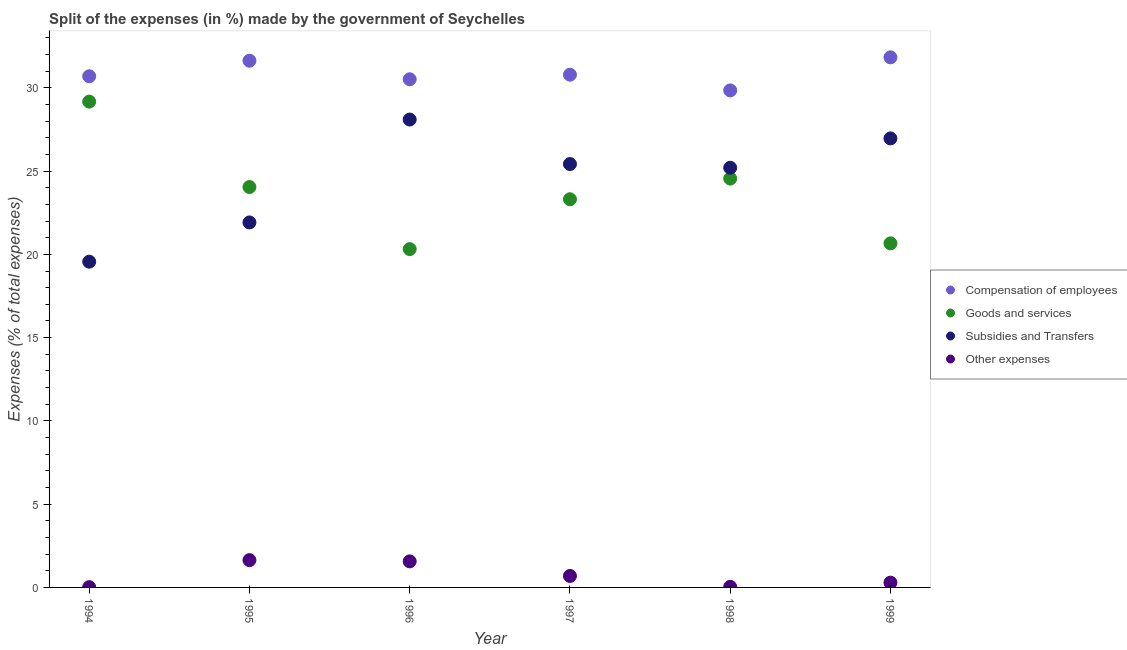What is the percentage of amount spent on subsidies in 1995?
Ensure brevity in your answer.  21.92. Across all years, what is the maximum percentage of amount spent on goods and services?
Provide a short and direct response. 29.17. Across all years, what is the minimum percentage of amount spent on other expenses?
Provide a short and direct response. 0.02. In which year was the percentage of amount spent on goods and services maximum?
Offer a very short reply. 1994. What is the total percentage of amount spent on subsidies in the graph?
Provide a short and direct response. 147.17. What is the difference between the percentage of amount spent on compensation of employees in 1995 and that in 1996?
Make the answer very short. 1.12. What is the difference between the percentage of amount spent on goods and services in 1999 and the percentage of amount spent on other expenses in 1998?
Your answer should be very brief. 20.63. What is the average percentage of amount spent on goods and services per year?
Keep it short and to the point. 23.68. In the year 1997, what is the difference between the percentage of amount spent on compensation of employees and percentage of amount spent on other expenses?
Ensure brevity in your answer.  30.1. In how many years, is the percentage of amount spent on subsidies greater than 30 %?
Make the answer very short. 0. What is the ratio of the percentage of amount spent on other expenses in 1994 to that in 1996?
Provide a succinct answer. 0.01. What is the difference between the highest and the second highest percentage of amount spent on other expenses?
Your response must be concise. 0.07. What is the difference between the highest and the lowest percentage of amount spent on other expenses?
Your answer should be compact. 1.62. In how many years, is the percentage of amount spent on goods and services greater than the average percentage of amount spent on goods and services taken over all years?
Provide a short and direct response. 3. Is the sum of the percentage of amount spent on other expenses in 1994 and 1997 greater than the maximum percentage of amount spent on compensation of employees across all years?
Make the answer very short. No. Is it the case that in every year, the sum of the percentage of amount spent on other expenses and percentage of amount spent on compensation of employees is greater than the sum of percentage of amount spent on subsidies and percentage of amount spent on goods and services?
Keep it short and to the point. No. Is it the case that in every year, the sum of the percentage of amount spent on compensation of employees and percentage of amount spent on goods and services is greater than the percentage of amount spent on subsidies?
Make the answer very short. Yes. Does the percentage of amount spent on goods and services monotonically increase over the years?
Make the answer very short. No. Is the percentage of amount spent on other expenses strictly greater than the percentage of amount spent on goods and services over the years?
Ensure brevity in your answer.  No. Is the percentage of amount spent on other expenses strictly less than the percentage of amount spent on subsidies over the years?
Your answer should be very brief. Yes. How many dotlines are there?
Give a very brief answer. 4. How many years are there in the graph?
Your answer should be very brief. 6. What is the difference between two consecutive major ticks on the Y-axis?
Provide a succinct answer. 5. Are the values on the major ticks of Y-axis written in scientific E-notation?
Your answer should be very brief. No. Does the graph contain grids?
Provide a succinct answer. No. What is the title of the graph?
Keep it short and to the point. Split of the expenses (in %) made by the government of Seychelles. What is the label or title of the Y-axis?
Your answer should be compact. Expenses (% of total expenses). What is the Expenses (% of total expenses) in Compensation of employees in 1994?
Provide a succinct answer. 30.7. What is the Expenses (% of total expenses) in Goods and services in 1994?
Offer a terse response. 29.17. What is the Expenses (% of total expenses) of Subsidies and Transfers in 1994?
Offer a terse response. 19.56. What is the Expenses (% of total expenses) in Other expenses in 1994?
Keep it short and to the point. 0.02. What is the Expenses (% of total expenses) in Compensation of employees in 1995?
Give a very brief answer. 31.63. What is the Expenses (% of total expenses) in Goods and services in 1995?
Make the answer very short. 24.05. What is the Expenses (% of total expenses) of Subsidies and Transfers in 1995?
Your response must be concise. 21.92. What is the Expenses (% of total expenses) in Other expenses in 1995?
Provide a short and direct response. 1.64. What is the Expenses (% of total expenses) in Compensation of employees in 1996?
Make the answer very short. 30.51. What is the Expenses (% of total expenses) in Goods and services in 1996?
Your answer should be compact. 20.32. What is the Expenses (% of total expenses) of Subsidies and Transfers in 1996?
Provide a short and direct response. 28.1. What is the Expenses (% of total expenses) in Other expenses in 1996?
Ensure brevity in your answer.  1.57. What is the Expenses (% of total expenses) of Compensation of employees in 1997?
Offer a terse response. 30.79. What is the Expenses (% of total expenses) in Goods and services in 1997?
Your answer should be compact. 23.31. What is the Expenses (% of total expenses) in Subsidies and Transfers in 1997?
Your answer should be compact. 25.42. What is the Expenses (% of total expenses) of Other expenses in 1997?
Make the answer very short. 0.69. What is the Expenses (% of total expenses) of Compensation of employees in 1998?
Your response must be concise. 29.85. What is the Expenses (% of total expenses) of Goods and services in 1998?
Your answer should be very brief. 24.55. What is the Expenses (% of total expenses) in Subsidies and Transfers in 1998?
Give a very brief answer. 25.2. What is the Expenses (% of total expenses) of Other expenses in 1998?
Your answer should be very brief. 0.04. What is the Expenses (% of total expenses) in Compensation of employees in 1999?
Your response must be concise. 31.83. What is the Expenses (% of total expenses) in Goods and services in 1999?
Offer a terse response. 20.66. What is the Expenses (% of total expenses) in Subsidies and Transfers in 1999?
Provide a short and direct response. 26.96. What is the Expenses (% of total expenses) of Other expenses in 1999?
Provide a short and direct response. 0.29. Across all years, what is the maximum Expenses (% of total expenses) of Compensation of employees?
Give a very brief answer. 31.83. Across all years, what is the maximum Expenses (% of total expenses) in Goods and services?
Offer a terse response. 29.17. Across all years, what is the maximum Expenses (% of total expenses) in Subsidies and Transfers?
Your answer should be compact. 28.1. Across all years, what is the maximum Expenses (% of total expenses) in Other expenses?
Offer a terse response. 1.64. Across all years, what is the minimum Expenses (% of total expenses) in Compensation of employees?
Your answer should be very brief. 29.85. Across all years, what is the minimum Expenses (% of total expenses) of Goods and services?
Your response must be concise. 20.32. Across all years, what is the minimum Expenses (% of total expenses) in Subsidies and Transfers?
Your response must be concise. 19.56. Across all years, what is the minimum Expenses (% of total expenses) of Other expenses?
Your answer should be compact. 0.02. What is the total Expenses (% of total expenses) in Compensation of employees in the graph?
Provide a succinct answer. 185.31. What is the total Expenses (% of total expenses) of Goods and services in the graph?
Your response must be concise. 142.06. What is the total Expenses (% of total expenses) of Subsidies and Transfers in the graph?
Provide a succinct answer. 147.17. What is the total Expenses (% of total expenses) in Other expenses in the graph?
Offer a terse response. 4.23. What is the difference between the Expenses (% of total expenses) in Compensation of employees in 1994 and that in 1995?
Your answer should be very brief. -0.93. What is the difference between the Expenses (% of total expenses) in Goods and services in 1994 and that in 1995?
Give a very brief answer. 5.13. What is the difference between the Expenses (% of total expenses) of Subsidies and Transfers in 1994 and that in 1995?
Your response must be concise. -2.36. What is the difference between the Expenses (% of total expenses) in Other expenses in 1994 and that in 1995?
Your response must be concise. -1.62. What is the difference between the Expenses (% of total expenses) in Compensation of employees in 1994 and that in 1996?
Your answer should be compact. 0.18. What is the difference between the Expenses (% of total expenses) of Goods and services in 1994 and that in 1996?
Offer a terse response. 8.86. What is the difference between the Expenses (% of total expenses) of Subsidies and Transfers in 1994 and that in 1996?
Offer a very short reply. -8.54. What is the difference between the Expenses (% of total expenses) in Other expenses in 1994 and that in 1996?
Make the answer very short. -1.55. What is the difference between the Expenses (% of total expenses) of Compensation of employees in 1994 and that in 1997?
Offer a terse response. -0.09. What is the difference between the Expenses (% of total expenses) in Goods and services in 1994 and that in 1997?
Ensure brevity in your answer.  5.86. What is the difference between the Expenses (% of total expenses) in Subsidies and Transfers in 1994 and that in 1997?
Keep it short and to the point. -5.86. What is the difference between the Expenses (% of total expenses) of Other expenses in 1994 and that in 1997?
Provide a succinct answer. -0.67. What is the difference between the Expenses (% of total expenses) in Compensation of employees in 1994 and that in 1998?
Offer a very short reply. 0.85. What is the difference between the Expenses (% of total expenses) in Goods and services in 1994 and that in 1998?
Provide a short and direct response. 4.62. What is the difference between the Expenses (% of total expenses) in Subsidies and Transfers in 1994 and that in 1998?
Ensure brevity in your answer.  -5.64. What is the difference between the Expenses (% of total expenses) of Other expenses in 1994 and that in 1998?
Keep it short and to the point. -0.02. What is the difference between the Expenses (% of total expenses) of Compensation of employees in 1994 and that in 1999?
Ensure brevity in your answer.  -1.14. What is the difference between the Expenses (% of total expenses) in Goods and services in 1994 and that in 1999?
Offer a very short reply. 8.51. What is the difference between the Expenses (% of total expenses) of Subsidies and Transfers in 1994 and that in 1999?
Make the answer very short. -7.4. What is the difference between the Expenses (% of total expenses) of Other expenses in 1994 and that in 1999?
Your answer should be very brief. -0.27. What is the difference between the Expenses (% of total expenses) in Compensation of employees in 1995 and that in 1996?
Ensure brevity in your answer.  1.12. What is the difference between the Expenses (% of total expenses) of Goods and services in 1995 and that in 1996?
Your answer should be compact. 3.73. What is the difference between the Expenses (% of total expenses) in Subsidies and Transfers in 1995 and that in 1996?
Provide a succinct answer. -6.18. What is the difference between the Expenses (% of total expenses) in Other expenses in 1995 and that in 1996?
Provide a short and direct response. 0.07. What is the difference between the Expenses (% of total expenses) in Compensation of employees in 1995 and that in 1997?
Make the answer very short. 0.84. What is the difference between the Expenses (% of total expenses) in Goods and services in 1995 and that in 1997?
Offer a very short reply. 0.73. What is the difference between the Expenses (% of total expenses) of Subsidies and Transfers in 1995 and that in 1997?
Keep it short and to the point. -3.51. What is the difference between the Expenses (% of total expenses) of Other expenses in 1995 and that in 1997?
Offer a very short reply. 0.95. What is the difference between the Expenses (% of total expenses) in Compensation of employees in 1995 and that in 1998?
Provide a succinct answer. 1.78. What is the difference between the Expenses (% of total expenses) of Goods and services in 1995 and that in 1998?
Your answer should be compact. -0.51. What is the difference between the Expenses (% of total expenses) in Subsidies and Transfers in 1995 and that in 1998?
Offer a terse response. -3.28. What is the difference between the Expenses (% of total expenses) of Other expenses in 1995 and that in 1998?
Provide a succinct answer. 1.6. What is the difference between the Expenses (% of total expenses) in Compensation of employees in 1995 and that in 1999?
Ensure brevity in your answer.  -0.2. What is the difference between the Expenses (% of total expenses) of Goods and services in 1995 and that in 1999?
Offer a very short reply. 3.38. What is the difference between the Expenses (% of total expenses) of Subsidies and Transfers in 1995 and that in 1999?
Provide a succinct answer. -5.05. What is the difference between the Expenses (% of total expenses) in Other expenses in 1995 and that in 1999?
Make the answer very short. 1.35. What is the difference between the Expenses (% of total expenses) of Compensation of employees in 1996 and that in 1997?
Provide a short and direct response. -0.28. What is the difference between the Expenses (% of total expenses) in Goods and services in 1996 and that in 1997?
Give a very brief answer. -2.99. What is the difference between the Expenses (% of total expenses) of Subsidies and Transfers in 1996 and that in 1997?
Your response must be concise. 2.67. What is the difference between the Expenses (% of total expenses) in Other expenses in 1996 and that in 1997?
Make the answer very short. 0.88. What is the difference between the Expenses (% of total expenses) in Compensation of employees in 1996 and that in 1998?
Your answer should be compact. 0.67. What is the difference between the Expenses (% of total expenses) of Goods and services in 1996 and that in 1998?
Provide a succinct answer. -4.24. What is the difference between the Expenses (% of total expenses) of Subsidies and Transfers in 1996 and that in 1998?
Ensure brevity in your answer.  2.89. What is the difference between the Expenses (% of total expenses) in Other expenses in 1996 and that in 1998?
Your answer should be very brief. 1.53. What is the difference between the Expenses (% of total expenses) of Compensation of employees in 1996 and that in 1999?
Give a very brief answer. -1.32. What is the difference between the Expenses (% of total expenses) of Goods and services in 1996 and that in 1999?
Your answer should be very brief. -0.34. What is the difference between the Expenses (% of total expenses) of Subsidies and Transfers in 1996 and that in 1999?
Your response must be concise. 1.13. What is the difference between the Expenses (% of total expenses) of Other expenses in 1996 and that in 1999?
Provide a succinct answer. 1.28. What is the difference between the Expenses (% of total expenses) of Compensation of employees in 1997 and that in 1998?
Offer a terse response. 0.94. What is the difference between the Expenses (% of total expenses) of Goods and services in 1997 and that in 1998?
Provide a short and direct response. -1.24. What is the difference between the Expenses (% of total expenses) in Subsidies and Transfers in 1997 and that in 1998?
Ensure brevity in your answer.  0.22. What is the difference between the Expenses (% of total expenses) in Other expenses in 1997 and that in 1998?
Offer a terse response. 0.65. What is the difference between the Expenses (% of total expenses) in Compensation of employees in 1997 and that in 1999?
Your answer should be very brief. -1.04. What is the difference between the Expenses (% of total expenses) of Goods and services in 1997 and that in 1999?
Your answer should be very brief. 2.65. What is the difference between the Expenses (% of total expenses) in Subsidies and Transfers in 1997 and that in 1999?
Keep it short and to the point. -1.54. What is the difference between the Expenses (% of total expenses) of Other expenses in 1997 and that in 1999?
Provide a succinct answer. 0.4. What is the difference between the Expenses (% of total expenses) of Compensation of employees in 1998 and that in 1999?
Provide a succinct answer. -1.99. What is the difference between the Expenses (% of total expenses) of Goods and services in 1998 and that in 1999?
Your answer should be very brief. 3.89. What is the difference between the Expenses (% of total expenses) in Subsidies and Transfers in 1998 and that in 1999?
Make the answer very short. -1.76. What is the difference between the Expenses (% of total expenses) in Other expenses in 1998 and that in 1999?
Offer a terse response. -0.25. What is the difference between the Expenses (% of total expenses) of Compensation of employees in 1994 and the Expenses (% of total expenses) of Goods and services in 1995?
Keep it short and to the point. 6.65. What is the difference between the Expenses (% of total expenses) of Compensation of employees in 1994 and the Expenses (% of total expenses) of Subsidies and Transfers in 1995?
Make the answer very short. 8.78. What is the difference between the Expenses (% of total expenses) in Compensation of employees in 1994 and the Expenses (% of total expenses) in Other expenses in 1995?
Provide a succinct answer. 29.06. What is the difference between the Expenses (% of total expenses) of Goods and services in 1994 and the Expenses (% of total expenses) of Subsidies and Transfers in 1995?
Offer a terse response. 7.26. What is the difference between the Expenses (% of total expenses) of Goods and services in 1994 and the Expenses (% of total expenses) of Other expenses in 1995?
Your answer should be very brief. 27.54. What is the difference between the Expenses (% of total expenses) of Subsidies and Transfers in 1994 and the Expenses (% of total expenses) of Other expenses in 1995?
Offer a terse response. 17.92. What is the difference between the Expenses (% of total expenses) in Compensation of employees in 1994 and the Expenses (% of total expenses) in Goods and services in 1996?
Give a very brief answer. 10.38. What is the difference between the Expenses (% of total expenses) of Compensation of employees in 1994 and the Expenses (% of total expenses) of Subsidies and Transfers in 1996?
Provide a succinct answer. 2.6. What is the difference between the Expenses (% of total expenses) of Compensation of employees in 1994 and the Expenses (% of total expenses) of Other expenses in 1996?
Provide a short and direct response. 29.13. What is the difference between the Expenses (% of total expenses) of Goods and services in 1994 and the Expenses (% of total expenses) of Subsidies and Transfers in 1996?
Ensure brevity in your answer.  1.08. What is the difference between the Expenses (% of total expenses) of Goods and services in 1994 and the Expenses (% of total expenses) of Other expenses in 1996?
Your answer should be compact. 27.61. What is the difference between the Expenses (% of total expenses) in Subsidies and Transfers in 1994 and the Expenses (% of total expenses) in Other expenses in 1996?
Your answer should be compact. 18. What is the difference between the Expenses (% of total expenses) in Compensation of employees in 1994 and the Expenses (% of total expenses) in Goods and services in 1997?
Your answer should be very brief. 7.39. What is the difference between the Expenses (% of total expenses) of Compensation of employees in 1994 and the Expenses (% of total expenses) of Subsidies and Transfers in 1997?
Keep it short and to the point. 5.27. What is the difference between the Expenses (% of total expenses) of Compensation of employees in 1994 and the Expenses (% of total expenses) of Other expenses in 1997?
Provide a short and direct response. 30.01. What is the difference between the Expenses (% of total expenses) in Goods and services in 1994 and the Expenses (% of total expenses) in Subsidies and Transfers in 1997?
Give a very brief answer. 3.75. What is the difference between the Expenses (% of total expenses) of Goods and services in 1994 and the Expenses (% of total expenses) of Other expenses in 1997?
Ensure brevity in your answer.  28.48. What is the difference between the Expenses (% of total expenses) of Subsidies and Transfers in 1994 and the Expenses (% of total expenses) of Other expenses in 1997?
Provide a succinct answer. 18.87. What is the difference between the Expenses (% of total expenses) in Compensation of employees in 1994 and the Expenses (% of total expenses) in Goods and services in 1998?
Offer a very short reply. 6.14. What is the difference between the Expenses (% of total expenses) in Compensation of employees in 1994 and the Expenses (% of total expenses) in Subsidies and Transfers in 1998?
Give a very brief answer. 5.49. What is the difference between the Expenses (% of total expenses) in Compensation of employees in 1994 and the Expenses (% of total expenses) in Other expenses in 1998?
Provide a short and direct response. 30.66. What is the difference between the Expenses (% of total expenses) in Goods and services in 1994 and the Expenses (% of total expenses) in Subsidies and Transfers in 1998?
Offer a terse response. 3.97. What is the difference between the Expenses (% of total expenses) in Goods and services in 1994 and the Expenses (% of total expenses) in Other expenses in 1998?
Your answer should be compact. 29.14. What is the difference between the Expenses (% of total expenses) in Subsidies and Transfers in 1994 and the Expenses (% of total expenses) in Other expenses in 1998?
Your answer should be very brief. 19.53. What is the difference between the Expenses (% of total expenses) in Compensation of employees in 1994 and the Expenses (% of total expenses) in Goods and services in 1999?
Give a very brief answer. 10.04. What is the difference between the Expenses (% of total expenses) of Compensation of employees in 1994 and the Expenses (% of total expenses) of Subsidies and Transfers in 1999?
Give a very brief answer. 3.73. What is the difference between the Expenses (% of total expenses) in Compensation of employees in 1994 and the Expenses (% of total expenses) in Other expenses in 1999?
Ensure brevity in your answer.  30.41. What is the difference between the Expenses (% of total expenses) of Goods and services in 1994 and the Expenses (% of total expenses) of Subsidies and Transfers in 1999?
Make the answer very short. 2.21. What is the difference between the Expenses (% of total expenses) in Goods and services in 1994 and the Expenses (% of total expenses) in Other expenses in 1999?
Your answer should be very brief. 28.89. What is the difference between the Expenses (% of total expenses) of Subsidies and Transfers in 1994 and the Expenses (% of total expenses) of Other expenses in 1999?
Offer a very short reply. 19.27. What is the difference between the Expenses (% of total expenses) of Compensation of employees in 1995 and the Expenses (% of total expenses) of Goods and services in 1996?
Provide a short and direct response. 11.31. What is the difference between the Expenses (% of total expenses) in Compensation of employees in 1995 and the Expenses (% of total expenses) in Subsidies and Transfers in 1996?
Ensure brevity in your answer.  3.53. What is the difference between the Expenses (% of total expenses) of Compensation of employees in 1995 and the Expenses (% of total expenses) of Other expenses in 1996?
Your answer should be very brief. 30.07. What is the difference between the Expenses (% of total expenses) of Goods and services in 1995 and the Expenses (% of total expenses) of Subsidies and Transfers in 1996?
Provide a succinct answer. -4.05. What is the difference between the Expenses (% of total expenses) of Goods and services in 1995 and the Expenses (% of total expenses) of Other expenses in 1996?
Make the answer very short. 22.48. What is the difference between the Expenses (% of total expenses) in Subsidies and Transfers in 1995 and the Expenses (% of total expenses) in Other expenses in 1996?
Provide a short and direct response. 20.35. What is the difference between the Expenses (% of total expenses) in Compensation of employees in 1995 and the Expenses (% of total expenses) in Goods and services in 1997?
Offer a very short reply. 8.32. What is the difference between the Expenses (% of total expenses) in Compensation of employees in 1995 and the Expenses (% of total expenses) in Subsidies and Transfers in 1997?
Give a very brief answer. 6.21. What is the difference between the Expenses (% of total expenses) in Compensation of employees in 1995 and the Expenses (% of total expenses) in Other expenses in 1997?
Your answer should be compact. 30.94. What is the difference between the Expenses (% of total expenses) of Goods and services in 1995 and the Expenses (% of total expenses) of Subsidies and Transfers in 1997?
Provide a succinct answer. -1.38. What is the difference between the Expenses (% of total expenses) in Goods and services in 1995 and the Expenses (% of total expenses) in Other expenses in 1997?
Give a very brief answer. 23.36. What is the difference between the Expenses (% of total expenses) of Subsidies and Transfers in 1995 and the Expenses (% of total expenses) of Other expenses in 1997?
Give a very brief answer. 21.23. What is the difference between the Expenses (% of total expenses) of Compensation of employees in 1995 and the Expenses (% of total expenses) of Goods and services in 1998?
Provide a succinct answer. 7.08. What is the difference between the Expenses (% of total expenses) of Compensation of employees in 1995 and the Expenses (% of total expenses) of Subsidies and Transfers in 1998?
Provide a short and direct response. 6.43. What is the difference between the Expenses (% of total expenses) in Compensation of employees in 1995 and the Expenses (% of total expenses) in Other expenses in 1998?
Your response must be concise. 31.59. What is the difference between the Expenses (% of total expenses) of Goods and services in 1995 and the Expenses (% of total expenses) of Subsidies and Transfers in 1998?
Make the answer very short. -1.16. What is the difference between the Expenses (% of total expenses) in Goods and services in 1995 and the Expenses (% of total expenses) in Other expenses in 1998?
Offer a very short reply. 24.01. What is the difference between the Expenses (% of total expenses) in Subsidies and Transfers in 1995 and the Expenses (% of total expenses) in Other expenses in 1998?
Ensure brevity in your answer.  21.88. What is the difference between the Expenses (% of total expenses) in Compensation of employees in 1995 and the Expenses (% of total expenses) in Goods and services in 1999?
Your response must be concise. 10.97. What is the difference between the Expenses (% of total expenses) of Compensation of employees in 1995 and the Expenses (% of total expenses) of Subsidies and Transfers in 1999?
Keep it short and to the point. 4.67. What is the difference between the Expenses (% of total expenses) in Compensation of employees in 1995 and the Expenses (% of total expenses) in Other expenses in 1999?
Keep it short and to the point. 31.34. What is the difference between the Expenses (% of total expenses) of Goods and services in 1995 and the Expenses (% of total expenses) of Subsidies and Transfers in 1999?
Give a very brief answer. -2.92. What is the difference between the Expenses (% of total expenses) of Goods and services in 1995 and the Expenses (% of total expenses) of Other expenses in 1999?
Provide a succinct answer. 23.76. What is the difference between the Expenses (% of total expenses) in Subsidies and Transfers in 1995 and the Expenses (% of total expenses) in Other expenses in 1999?
Your answer should be compact. 21.63. What is the difference between the Expenses (% of total expenses) in Compensation of employees in 1996 and the Expenses (% of total expenses) in Goods and services in 1997?
Your answer should be compact. 7.2. What is the difference between the Expenses (% of total expenses) of Compensation of employees in 1996 and the Expenses (% of total expenses) of Subsidies and Transfers in 1997?
Provide a succinct answer. 5.09. What is the difference between the Expenses (% of total expenses) in Compensation of employees in 1996 and the Expenses (% of total expenses) in Other expenses in 1997?
Provide a short and direct response. 29.82. What is the difference between the Expenses (% of total expenses) of Goods and services in 1996 and the Expenses (% of total expenses) of Subsidies and Transfers in 1997?
Your response must be concise. -5.11. What is the difference between the Expenses (% of total expenses) of Goods and services in 1996 and the Expenses (% of total expenses) of Other expenses in 1997?
Your answer should be compact. 19.63. What is the difference between the Expenses (% of total expenses) in Subsidies and Transfers in 1996 and the Expenses (% of total expenses) in Other expenses in 1997?
Give a very brief answer. 27.41. What is the difference between the Expenses (% of total expenses) in Compensation of employees in 1996 and the Expenses (% of total expenses) in Goods and services in 1998?
Keep it short and to the point. 5.96. What is the difference between the Expenses (% of total expenses) of Compensation of employees in 1996 and the Expenses (% of total expenses) of Subsidies and Transfers in 1998?
Provide a succinct answer. 5.31. What is the difference between the Expenses (% of total expenses) of Compensation of employees in 1996 and the Expenses (% of total expenses) of Other expenses in 1998?
Provide a succinct answer. 30.48. What is the difference between the Expenses (% of total expenses) in Goods and services in 1996 and the Expenses (% of total expenses) in Subsidies and Transfers in 1998?
Provide a succinct answer. -4.89. What is the difference between the Expenses (% of total expenses) in Goods and services in 1996 and the Expenses (% of total expenses) in Other expenses in 1998?
Your answer should be compact. 20.28. What is the difference between the Expenses (% of total expenses) of Subsidies and Transfers in 1996 and the Expenses (% of total expenses) of Other expenses in 1998?
Ensure brevity in your answer.  28.06. What is the difference between the Expenses (% of total expenses) of Compensation of employees in 1996 and the Expenses (% of total expenses) of Goods and services in 1999?
Your answer should be very brief. 9.85. What is the difference between the Expenses (% of total expenses) of Compensation of employees in 1996 and the Expenses (% of total expenses) of Subsidies and Transfers in 1999?
Your answer should be compact. 3.55. What is the difference between the Expenses (% of total expenses) in Compensation of employees in 1996 and the Expenses (% of total expenses) in Other expenses in 1999?
Provide a short and direct response. 30.23. What is the difference between the Expenses (% of total expenses) of Goods and services in 1996 and the Expenses (% of total expenses) of Subsidies and Transfers in 1999?
Ensure brevity in your answer.  -6.65. What is the difference between the Expenses (% of total expenses) of Goods and services in 1996 and the Expenses (% of total expenses) of Other expenses in 1999?
Your answer should be very brief. 20.03. What is the difference between the Expenses (% of total expenses) in Subsidies and Transfers in 1996 and the Expenses (% of total expenses) in Other expenses in 1999?
Make the answer very short. 27.81. What is the difference between the Expenses (% of total expenses) of Compensation of employees in 1997 and the Expenses (% of total expenses) of Goods and services in 1998?
Your answer should be compact. 6.24. What is the difference between the Expenses (% of total expenses) in Compensation of employees in 1997 and the Expenses (% of total expenses) in Subsidies and Transfers in 1998?
Keep it short and to the point. 5.59. What is the difference between the Expenses (% of total expenses) in Compensation of employees in 1997 and the Expenses (% of total expenses) in Other expenses in 1998?
Make the answer very short. 30.75. What is the difference between the Expenses (% of total expenses) of Goods and services in 1997 and the Expenses (% of total expenses) of Subsidies and Transfers in 1998?
Provide a succinct answer. -1.89. What is the difference between the Expenses (% of total expenses) in Goods and services in 1997 and the Expenses (% of total expenses) in Other expenses in 1998?
Ensure brevity in your answer.  23.27. What is the difference between the Expenses (% of total expenses) in Subsidies and Transfers in 1997 and the Expenses (% of total expenses) in Other expenses in 1998?
Keep it short and to the point. 25.39. What is the difference between the Expenses (% of total expenses) of Compensation of employees in 1997 and the Expenses (% of total expenses) of Goods and services in 1999?
Provide a succinct answer. 10.13. What is the difference between the Expenses (% of total expenses) of Compensation of employees in 1997 and the Expenses (% of total expenses) of Subsidies and Transfers in 1999?
Keep it short and to the point. 3.83. What is the difference between the Expenses (% of total expenses) of Compensation of employees in 1997 and the Expenses (% of total expenses) of Other expenses in 1999?
Your answer should be compact. 30.5. What is the difference between the Expenses (% of total expenses) in Goods and services in 1997 and the Expenses (% of total expenses) in Subsidies and Transfers in 1999?
Keep it short and to the point. -3.65. What is the difference between the Expenses (% of total expenses) of Goods and services in 1997 and the Expenses (% of total expenses) of Other expenses in 1999?
Make the answer very short. 23.02. What is the difference between the Expenses (% of total expenses) in Subsidies and Transfers in 1997 and the Expenses (% of total expenses) in Other expenses in 1999?
Your answer should be compact. 25.14. What is the difference between the Expenses (% of total expenses) of Compensation of employees in 1998 and the Expenses (% of total expenses) of Goods and services in 1999?
Your answer should be compact. 9.19. What is the difference between the Expenses (% of total expenses) of Compensation of employees in 1998 and the Expenses (% of total expenses) of Subsidies and Transfers in 1999?
Provide a succinct answer. 2.88. What is the difference between the Expenses (% of total expenses) in Compensation of employees in 1998 and the Expenses (% of total expenses) in Other expenses in 1999?
Make the answer very short. 29.56. What is the difference between the Expenses (% of total expenses) of Goods and services in 1998 and the Expenses (% of total expenses) of Subsidies and Transfers in 1999?
Your answer should be very brief. -2.41. What is the difference between the Expenses (% of total expenses) in Goods and services in 1998 and the Expenses (% of total expenses) in Other expenses in 1999?
Your response must be concise. 24.27. What is the difference between the Expenses (% of total expenses) of Subsidies and Transfers in 1998 and the Expenses (% of total expenses) of Other expenses in 1999?
Provide a short and direct response. 24.92. What is the average Expenses (% of total expenses) of Compensation of employees per year?
Offer a very short reply. 30.89. What is the average Expenses (% of total expenses) of Goods and services per year?
Make the answer very short. 23.68. What is the average Expenses (% of total expenses) in Subsidies and Transfers per year?
Make the answer very short. 24.53. What is the average Expenses (% of total expenses) of Other expenses per year?
Make the answer very short. 0.71. In the year 1994, what is the difference between the Expenses (% of total expenses) of Compensation of employees and Expenses (% of total expenses) of Goods and services?
Offer a terse response. 1.52. In the year 1994, what is the difference between the Expenses (% of total expenses) of Compensation of employees and Expenses (% of total expenses) of Subsidies and Transfers?
Your response must be concise. 11.13. In the year 1994, what is the difference between the Expenses (% of total expenses) of Compensation of employees and Expenses (% of total expenses) of Other expenses?
Give a very brief answer. 30.68. In the year 1994, what is the difference between the Expenses (% of total expenses) of Goods and services and Expenses (% of total expenses) of Subsidies and Transfers?
Ensure brevity in your answer.  9.61. In the year 1994, what is the difference between the Expenses (% of total expenses) in Goods and services and Expenses (% of total expenses) in Other expenses?
Your answer should be very brief. 29.16. In the year 1994, what is the difference between the Expenses (% of total expenses) in Subsidies and Transfers and Expenses (% of total expenses) in Other expenses?
Provide a succinct answer. 19.54. In the year 1995, what is the difference between the Expenses (% of total expenses) in Compensation of employees and Expenses (% of total expenses) in Goods and services?
Ensure brevity in your answer.  7.59. In the year 1995, what is the difference between the Expenses (% of total expenses) in Compensation of employees and Expenses (% of total expenses) in Subsidies and Transfers?
Offer a terse response. 9.71. In the year 1995, what is the difference between the Expenses (% of total expenses) in Compensation of employees and Expenses (% of total expenses) in Other expenses?
Keep it short and to the point. 29.99. In the year 1995, what is the difference between the Expenses (% of total expenses) of Goods and services and Expenses (% of total expenses) of Subsidies and Transfers?
Your answer should be compact. 2.13. In the year 1995, what is the difference between the Expenses (% of total expenses) of Goods and services and Expenses (% of total expenses) of Other expenses?
Provide a succinct answer. 22.41. In the year 1995, what is the difference between the Expenses (% of total expenses) of Subsidies and Transfers and Expenses (% of total expenses) of Other expenses?
Keep it short and to the point. 20.28. In the year 1996, what is the difference between the Expenses (% of total expenses) in Compensation of employees and Expenses (% of total expenses) in Goods and services?
Ensure brevity in your answer.  10.2. In the year 1996, what is the difference between the Expenses (% of total expenses) in Compensation of employees and Expenses (% of total expenses) in Subsidies and Transfers?
Offer a terse response. 2.42. In the year 1996, what is the difference between the Expenses (% of total expenses) in Compensation of employees and Expenses (% of total expenses) in Other expenses?
Offer a terse response. 28.95. In the year 1996, what is the difference between the Expenses (% of total expenses) of Goods and services and Expenses (% of total expenses) of Subsidies and Transfers?
Keep it short and to the point. -7.78. In the year 1996, what is the difference between the Expenses (% of total expenses) of Goods and services and Expenses (% of total expenses) of Other expenses?
Ensure brevity in your answer.  18.75. In the year 1996, what is the difference between the Expenses (% of total expenses) of Subsidies and Transfers and Expenses (% of total expenses) of Other expenses?
Make the answer very short. 26.53. In the year 1997, what is the difference between the Expenses (% of total expenses) in Compensation of employees and Expenses (% of total expenses) in Goods and services?
Offer a terse response. 7.48. In the year 1997, what is the difference between the Expenses (% of total expenses) in Compensation of employees and Expenses (% of total expenses) in Subsidies and Transfers?
Your answer should be very brief. 5.37. In the year 1997, what is the difference between the Expenses (% of total expenses) of Compensation of employees and Expenses (% of total expenses) of Other expenses?
Provide a succinct answer. 30.1. In the year 1997, what is the difference between the Expenses (% of total expenses) in Goods and services and Expenses (% of total expenses) in Subsidies and Transfers?
Your answer should be compact. -2.11. In the year 1997, what is the difference between the Expenses (% of total expenses) of Goods and services and Expenses (% of total expenses) of Other expenses?
Give a very brief answer. 22.62. In the year 1997, what is the difference between the Expenses (% of total expenses) of Subsidies and Transfers and Expenses (% of total expenses) of Other expenses?
Make the answer very short. 24.73. In the year 1998, what is the difference between the Expenses (% of total expenses) of Compensation of employees and Expenses (% of total expenses) of Goods and services?
Keep it short and to the point. 5.29. In the year 1998, what is the difference between the Expenses (% of total expenses) of Compensation of employees and Expenses (% of total expenses) of Subsidies and Transfers?
Provide a short and direct response. 4.64. In the year 1998, what is the difference between the Expenses (% of total expenses) in Compensation of employees and Expenses (% of total expenses) in Other expenses?
Make the answer very short. 29.81. In the year 1998, what is the difference between the Expenses (% of total expenses) in Goods and services and Expenses (% of total expenses) in Subsidies and Transfers?
Keep it short and to the point. -0.65. In the year 1998, what is the difference between the Expenses (% of total expenses) of Goods and services and Expenses (% of total expenses) of Other expenses?
Your answer should be compact. 24.52. In the year 1998, what is the difference between the Expenses (% of total expenses) of Subsidies and Transfers and Expenses (% of total expenses) of Other expenses?
Keep it short and to the point. 25.17. In the year 1999, what is the difference between the Expenses (% of total expenses) of Compensation of employees and Expenses (% of total expenses) of Goods and services?
Offer a very short reply. 11.17. In the year 1999, what is the difference between the Expenses (% of total expenses) of Compensation of employees and Expenses (% of total expenses) of Subsidies and Transfers?
Keep it short and to the point. 4.87. In the year 1999, what is the difference between the Expenses (% of total expenses) of Compensation of employees and Expenses (% of total expenses) of Other expenses?
Provide a succinct answer. 31.55. In the year 1999, what is the difference between the Expenses (% of total expenses) of Goods and services and Expenses (% of total expenses) of Subsidies and Transfers?
Keep it short and to the point. -6.3. In the year 1999, what is the difference between the Expenses (% of total expenses) in Goods and services and Expenses (% of total expenses) in Other expenses?
Provide a succinct answer. 20.37. In the year 1999, what is the difference between the Expenses (% of total expenses) in Subsidies and Transfers and Expenses (% of total expenses) in Other expenses?
Give a very brief answer. 26.68. What is the ratio of the Expenses (% of total expenses) in Compensation of employees in 1994 to that in 1995?
Your response must be concise. 0.97. What is the ratio of the Expenses (% of total expenses) in Goods and services in 1994 to that in 1995?
Offer a very short reply. 1.21. What is the ratio of the Expenses (% of total expenses) of Subsidies and Transfers in 1994 to that in 1995?
Your answer should be compact. 0.89. What is the ratio of the Expenses (% of total expenses) in Other expenses in 1994 to that in 1995?
Your response must be concise. 0.01. What is the ratio of the Expenses (% of total expenses) of Compensation of employees in 1994 to that in 1996?
Provide a succinct answer. 1.01. What is the ratio of the Expenses (% of total expenses) in Goods and services in 1994 to that in 1996?
Provide a succinct answer. 1.44. What is the ratio of the Expenses (% of total expenses) in Subsidies and Transfers in 1994 to that in 1996?
Your answer should be very brief. 0.7. What is the ratio of the Expenses (% of total expenses) in Other expenses in 1994 to that in 1996?
Give a very brief answer. 0.01. What is the ratio of the Expenses (% of total expenses) in Compensation of employees in 1994 to that in 1997?
Offer a terse response. 1. What is the ratio of the Expenses (% of total expenses) of Goods and services in 1994 to that in 1997?
Give a very brief answer. 1.25. What is the ratio of the Expenses (% of total expenses) in Subsidies and Transfers in 1994 to that in 1997?
Offer a very short reply. 0.77. What is the ratio of the Expenses (% of total expenses) in Other expenses in 1994 to that in 1997?
Keep it short and to the point. 0.02. What is the ratio of the Expenses (% of total expenses) of Compensation of employees in 1994 to that in 1998?
Keep it short and to the point. 1.03. What is the ratio of the Expenses (% of total expenses) of Goods and services in 1994 to that in 1998?
Your response must be concise. 1.19. What is the ratio of the Expenses (% of total expenses) of Subsidies and Transfers in 1994 to that in 1998?
Offer a very short reply. 0.78. What is the ratio of the Expenses (% of total expenses) in Other expenses in 1994 to that in 1998?
Give a very brief answer. 0.46. What is the ratio of the Expenses (% of total expenses) of Compensation of employees in 1994 to that in 1999?
Keep it short and to the point. 0.96. What is the ratio of the Expenses (% of total expenses) in Goods and services in 1994 to that in 1999?
Offer a very short reply. 1.41. What is the ratio of the Expenses (% of total expenses) in Subsidies and Transfers in 1994 to that in 1999?
Your answer should be very brief. 0.73. What is the ratio of the Expenses (% of total expenses) in Other expenses in 1994 to that in 1999?
Provide a succinct answer. 0.06. What is the ratio of the Expenses (% of total expenses) in Compensation of employees in 1995 to that in 1996?
Provide a succinct answer. 1.04. What is the ratio of the Expenses (% of total expenses) in Goods and services in 1995 to that in 1996?
Your answer should be compact. 1.18. What is the ratio of the Expenses (% of total expenses) of Subsidies and Transfers in 1995 to that in 1996?
Your answer should be very brief. 0.78. What is the ratio of the Expenses (% of total expenses) of Other expenses in 1995 to that in 1996?
Ensure brevity in your answer.  1.05. What is the ratio of the Expenses (% of total expenses) of Compensation of employees in 1995 to that in 1997?
Offer a terse response. 1.03. What is the ratio of the Expenses (% of total expenses) of Goods and services in 1995 to that in 1997?
Offer a very short reply. 1.03. What is the ratio of the Expenses (% of total expenses) in Subsidies and Transfers in 1995 to that in 1997?
Provide a succinct answer. 0.86. What is the ratio of the Expenses (% of total expenses) of Other expenses in 1995 to that in 1997?
Offer a very short reply. 2.38. What is the ratio of the Expenses (% of total expenses) in Compensation of employees in 1995 to that in 1998?
Your answer should be compact. 1.06. What is the ratio of the Expenses (% of total expenses) of Goods and services in 1995 to that in 1998?
Make the answer very short. 0.98. What is the ratio of the Expenses (% of total expenses) of Subsidies and Transfers in 1995 to that in 1998?
Your response must be concise. 0.87. What is the ratio of the Expenses (% of total expenses) of Other expenses in 1995 to that in 1998?
Ensure brevity in your answer.  45.58. What is the ratio of the Expenses (% of total expenses) in Compensation of employees in 1995 to that in 1999?
Your answer should be compact. 0.99. What is the ratio of the Expenses (% of total expenses) in Goods and services in 1995 to that in 1999?
Ensure brevity in your answer.  1.16. What is the ratio of the Expenses (% of total expenses) in Subsidies and Transfers in 1995 to that in 1999?
Provide a short and direct response. 0.81. What is the ratio of the Expenses (% of total expenses) in Other expenses in 1995 to that in 1999?
Your answer should be compact. 5.72. What is the ratio of the Expenses (% of total expenses) of Goods and services in 1996 to that in 1997?
Your answer should be very brief. 0.87. What is the ratio of the Expenses (% of total expenses) in Subsidies and Transfers in 1996 to that in 1997?
Provide a short and direct response. 1.11. What is the ratio of the Expenses (% of total expenses) in Other expenses in 1996 to that in 1997?
Your answer should be very brief. 2.27. What is the ratio of the Expenses (% of total expenses) of Compensation of employees in 1996 to that in 1998?
Your answer should be very brief. 1.02. What is the ratio of the Expenses (% of total expenses) in Goods and services in 1996 to that in 1998?
Your response must be concise. 0.83. What is the ratio of the Expenses (% of total expenses) of Subsidies and Transfers in 1996 to that in 1998?
Make the answer very short. 1.11. What is the ratio of the Expenses (% of total expenses) of Other expenses in 1996 to that in 1998?
Your answer should be very brief. 43.52. What is the ratio of the Expenses (% of total expenses) of Compensation of employees in 1996 to that in 1999?
Provide a short and direct response. 0.96. What is the ratio of the Expenses (% of total expenses) in Goods and services in 1996 to that in 1999?
Your answer should be very brief. 0.98. What is the ratio of the Expenses (% of total expenses) in Subsidies and Transfers in 1996 to that in 1999?
Keep it short and to the point. 1.04. What is the ratio of the Expenses (% of total expenses) in Other expenses in 1996 to that in 1999?
Provide a succinct answer. 5.46. What is the ratio of the Expenses (% of total expenses) in Compensation of employees in 1997 to that in 1998?
Keep it short and to the point. 1.03. What is the ratio of the Expenses (% of total expenses) in Goods and services in 1997 to that in 1998?
Offer a very short reply. 0.95. What is the ratio of the Expenses (% of total expenses) in Subsidies and Transfers in 1997 to that in 1998?
Provide a short and direct response. 1.01. What is the ratio of the Expenses (% of total expenses) in Other expenses in 1997 to that in 1998?
Provide a succinct answer. 19.18. What is the ratio of the Expenses (% of total expenses) of Compensation of employees in 1997 to that in 1999?
Ensure brevity in your answer.  0.97. What is the ratio of the Expenses (% of total expenses) of Goods and services in 1997 to that in 1999?
Give a very brief answer. 1.13. What is the ratio of the Expenses (% of total expenses) in Subsidies and Transfers in 1997 to that in 1999?
Your response must be concise. 0.94. What is the ratio of the Expenses (% of total expenses) in Other expenses in 1997 to that in 1999?
Offer a very short reply. 2.41. What is the ratio of the Expenses (% of total expenses) in Compensation of employees in 1998 to that in 1999?
Your answer should be very brief. 0.94. What is the ratio of the Expenses (% of total expenses) in Goods and services in 1998 to that in 1999?
Provide a short and direct response. 1.19. What is the ratio of the Expenses (% of total expenses) of Subsidies and Transfers in 1998 to that in 1999?
Provide a succinct answer. 0.93. What is the ratio of the Expenses (% of total expenses) in Other expenses in 1998 to that in 1999?
Provide a short and direct response. 0.13. What is the difference between the highest and the second highest Expenses (% of total expenses) of Compensation of employees?
Your answer should be very brief. 0.2. What is the difference between the highest and the second highest Expenses (% of total expenses) of Goods and services?
Offer a terse response. 4.62. What is the difference between the highest and the second highest Expenses (% of total expenses) in Subsidies and Transfers?
Your answer should be very brief. 1.13. What is the difference between the highest and the second highest Expenses (% of total expenses) in Other expenses?
Offer a terse response. 0.07. What is the difference between the highest and the lowest Expenses (% of total expenses) in Compensation of employees?
Make the answer very short. 1.99. What is the difference between the highest and the lowest Expenses (% of total expenses) of Goods and services?
Your answer should be very brief. 8.86. What is the difference between the highest and the lowest Expenses (% of total expenses) in Subsidies and Transfers?
Offer a terse response. 8.54. What is the difference between the highest and the lowest Expenses (% of total expenses) of Other expenses?
Your answer should be very brief. 1.62. 